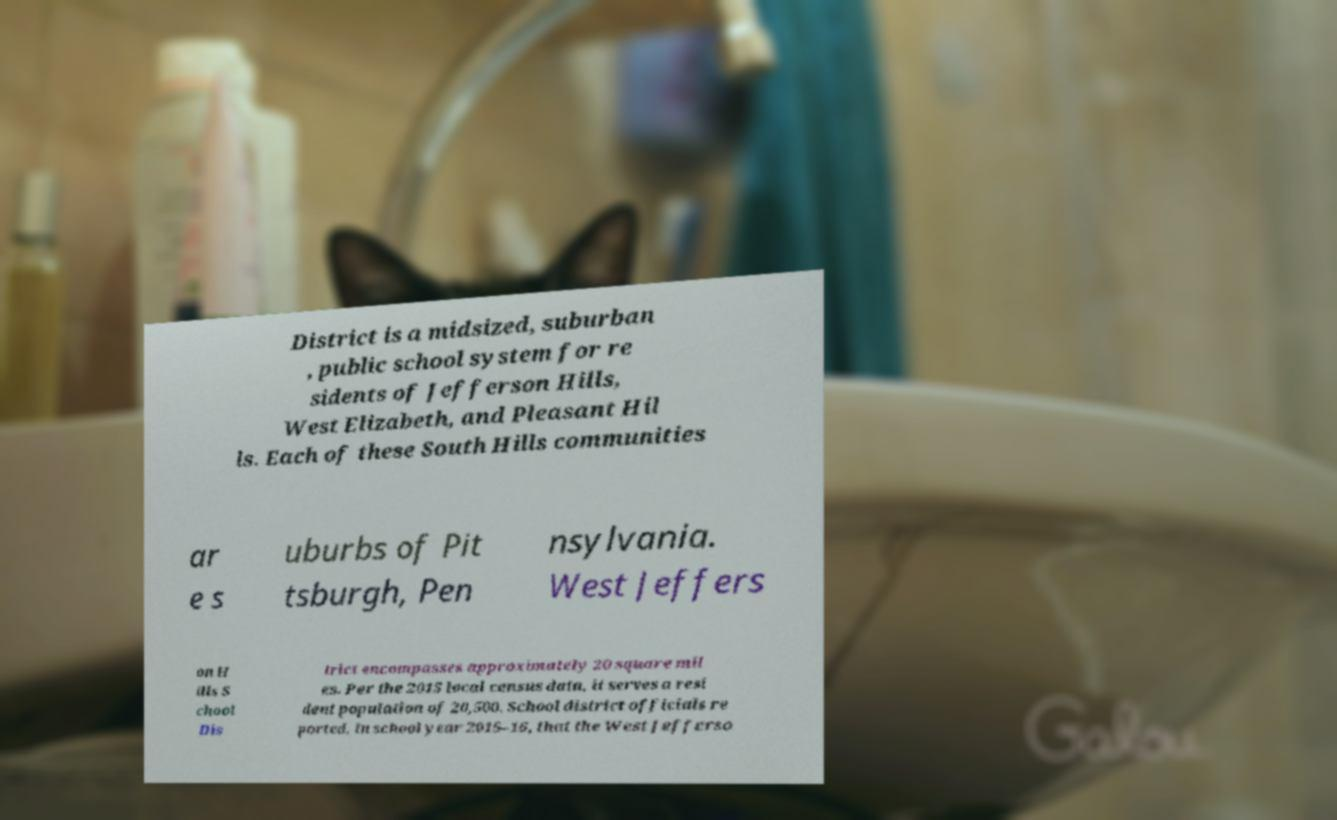Can you read and provide the text displayed in the image?This photo seems to have some interesting text. Can you extract and type it out for me? District is a midsized, suburban , public school system for re sidents of Jefferson Hills, West Elizabeth, and Pleasant Hil ls. Each of these South Hills communities ar e s uburbs of Pit tsburgh, Pen nsylvania. West Jeffers on H ills S chool Dis trict encompasses approximately 20 square mil es. Per the 2015 local census data, it serves a resi dent population of 20,500. School district officials re ported, in school year 2015–16, that the West Jefferso 